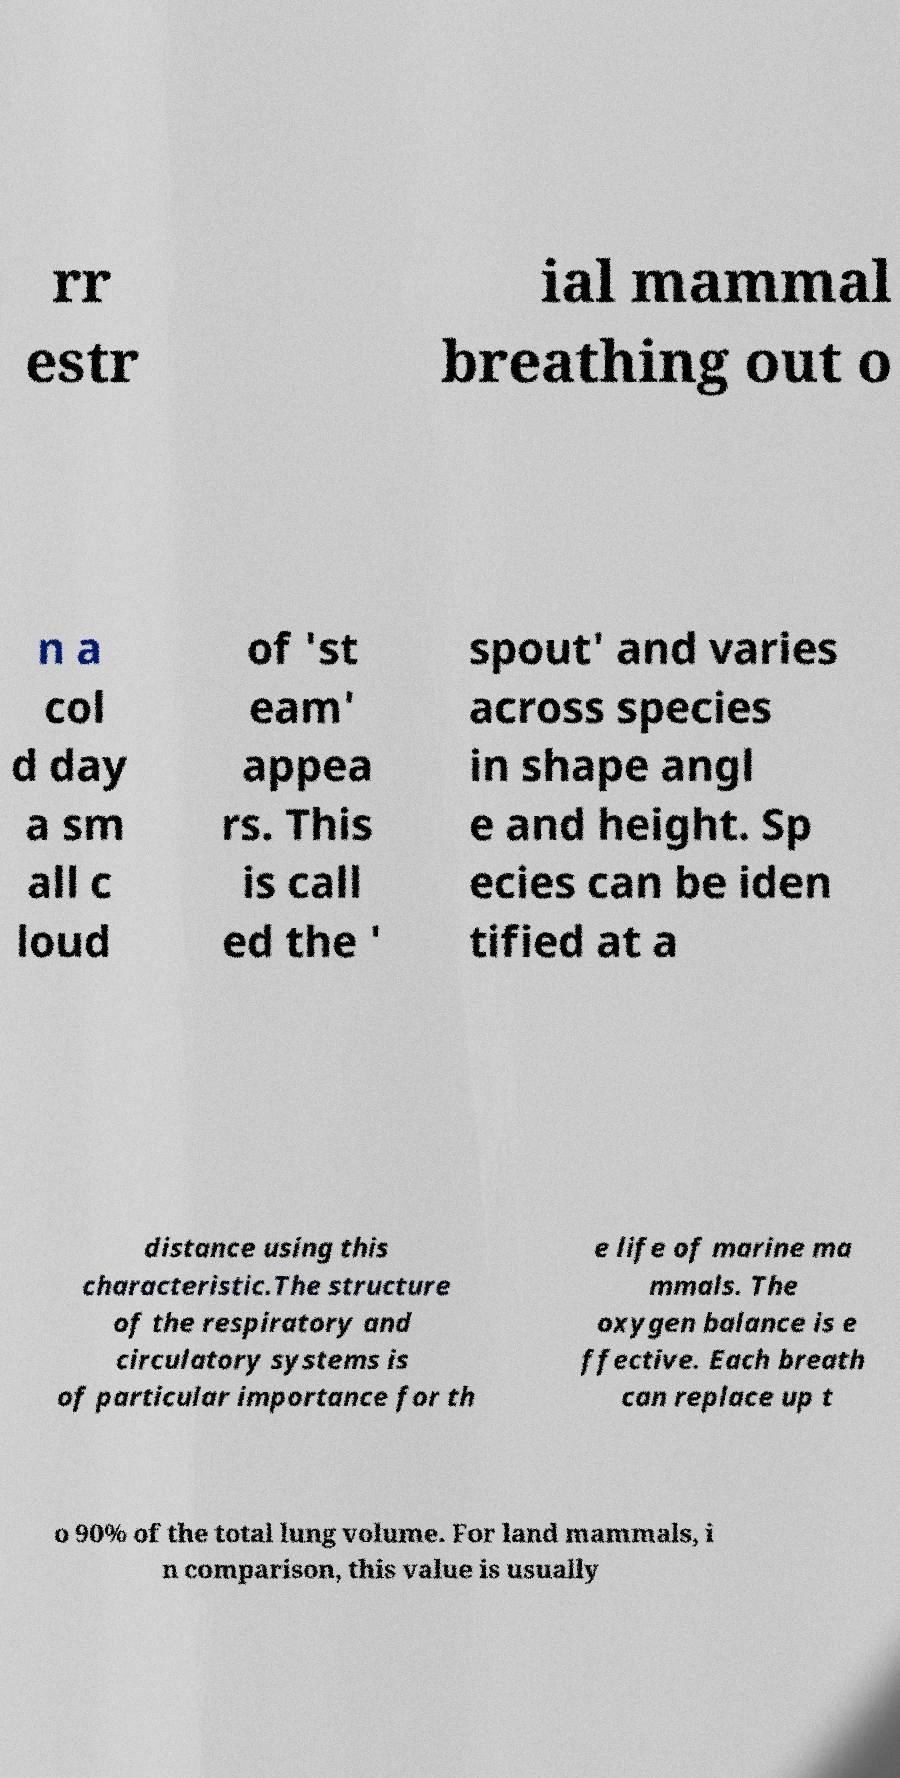I need the written content from this picture converted into text. Can you do that? rr estr ial mammal breathing out o n a col d day a sm all c loud of 'st eam' appea rs. This is call ed the ' spout' and varies across species in shape angl e and height. Sp ecies can be iden tified at a distance using this characteristic.The structure of the respiratory and circulatory systems is of particular importance for th e life of marine ma mmals. The oxygen balance is e ffective. Each breath can replace up t o 90% of the total lung volume. For land mammals, i n comparison, this value is usually 